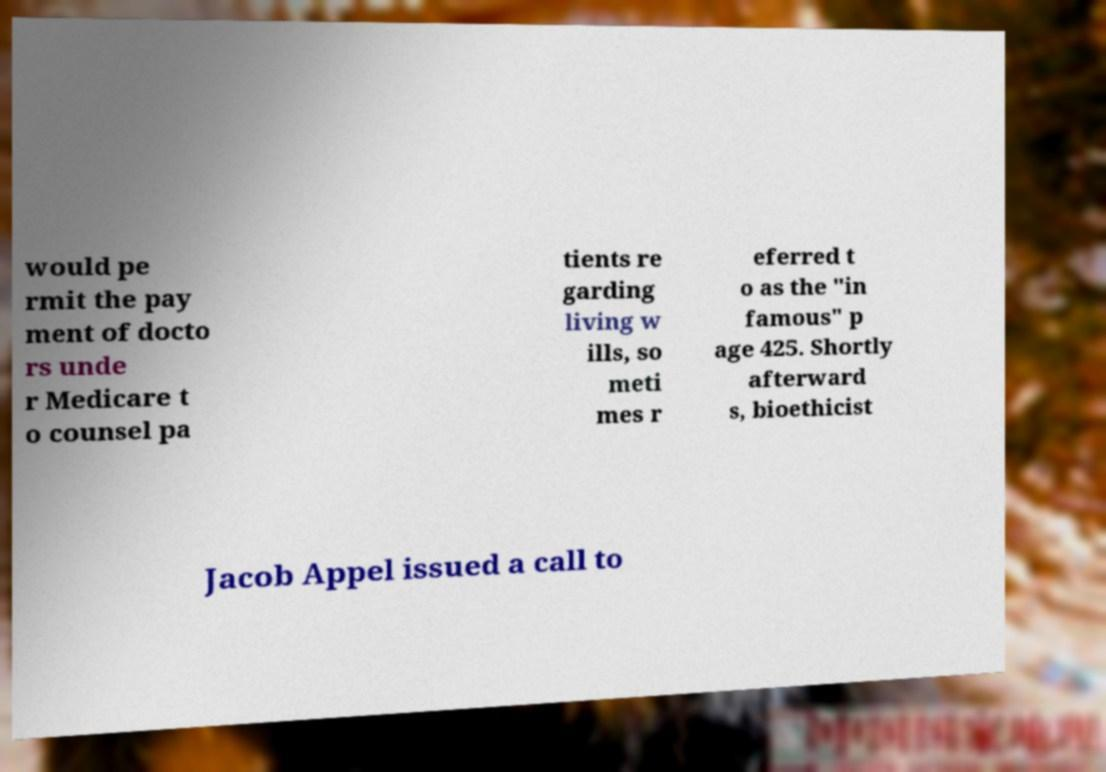Please identify and transcribe the text found in this image. would pe rmit the pay ment of docto rs unde r Medicare t o counsel pa tients re garding living w ills, so meti mes r eferred t o as the "in famous" p age 425. Shortly afterward s, bioethicist Jacob Appel issued a call to 